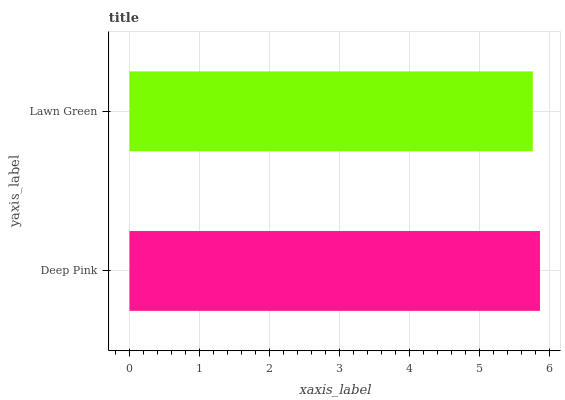Is Lawn Green the minimum?
Answer yes or no. Yes. Is Deep Pink the maximum?
Answer yes or no. Yes. Is Lawn Green the maximum?
Answer yes or no. No. Is Deep Pink greater than Lawn Green?
Answer yes or no. Yes. Is Lawn Green less than Deep Pink?
Answer yes or no. Yes. Is Lawn Green greater than Deep Pink?
Answer yes or no. No. Is Deep Pink less than Lawn Green?
Answer yes or no. No. Is Deep Pink the high median?
Answer yes or no. Yes. Is Lawn Green the low median?
Answer yes or no. Yes. Is Lawn Green the high median?
Answer yes or no. No. Is Deep Pink the low median?
Answer yes or no. No. 